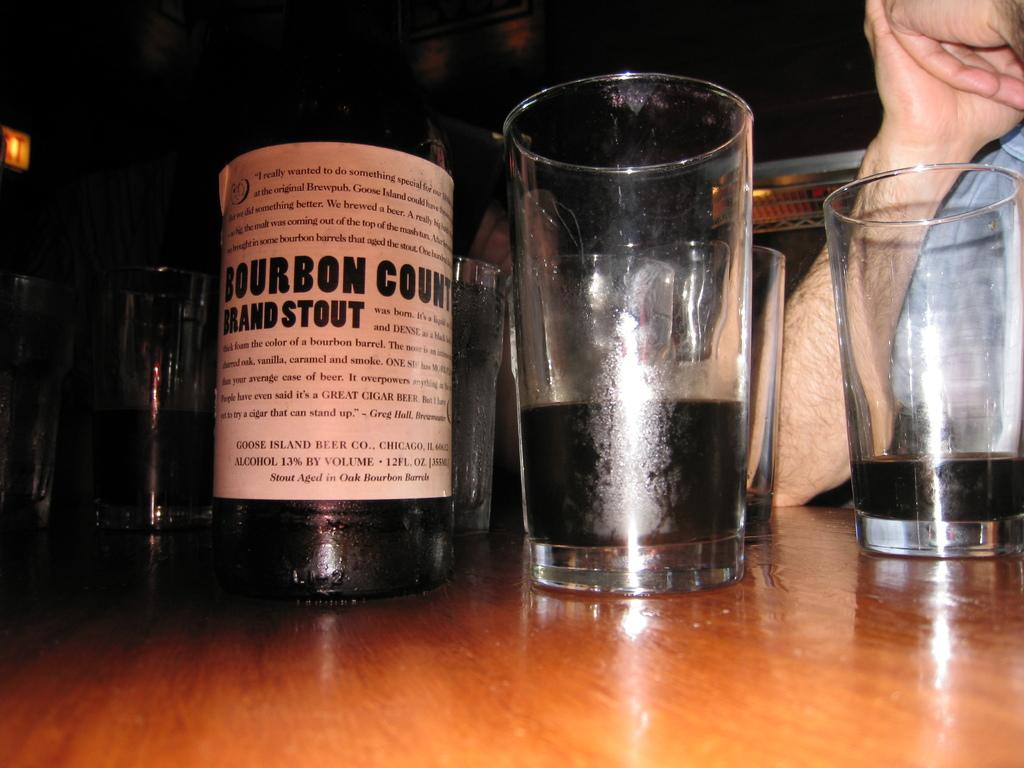<image>
Describe the image concisely. a bourbon that is on a table next to other stuff 